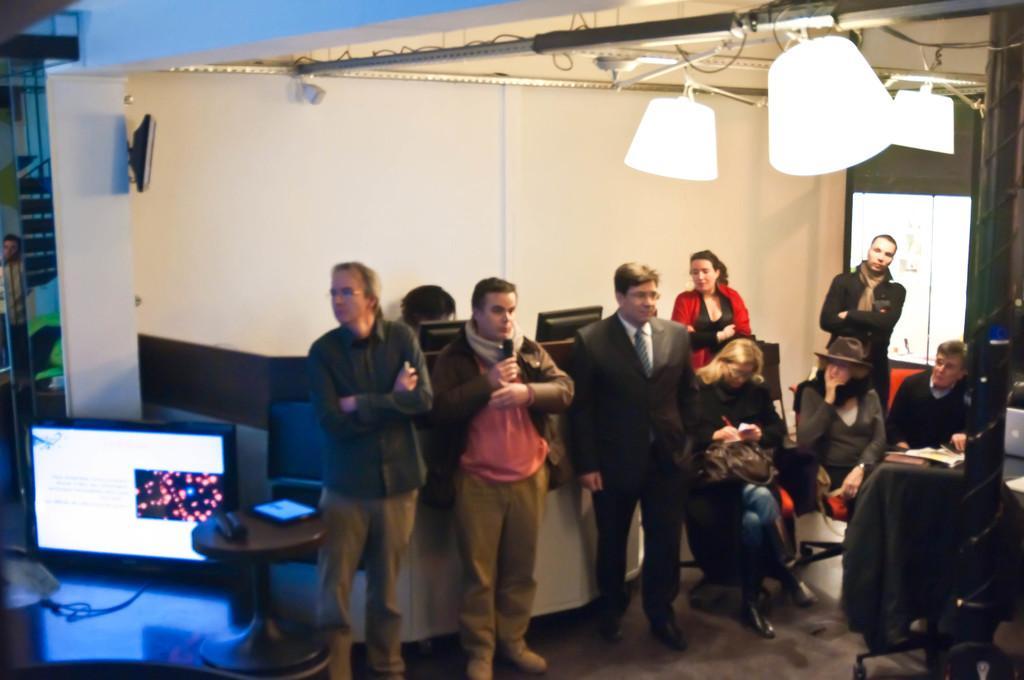How would you summarize this image in a sentence or two? On the background we can see a wall. At the top of the ceiling we can see a television here. We can see persons standing on the floor and sitting on chairs. 